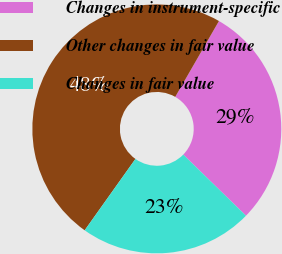<chart> <loc_0><loc_0><loc_500><loc_500><pie_chart><fcel>Changes in instrument-specific<fcel>Other changes in fair value<fcel>Changes in fair value<nl><fcel>28.97%<fcel>48.48%<fcel>22.55%<nl></chart> 